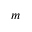<formula> <loc_0><loc_0><loc_500><loc_500>m</formula> 